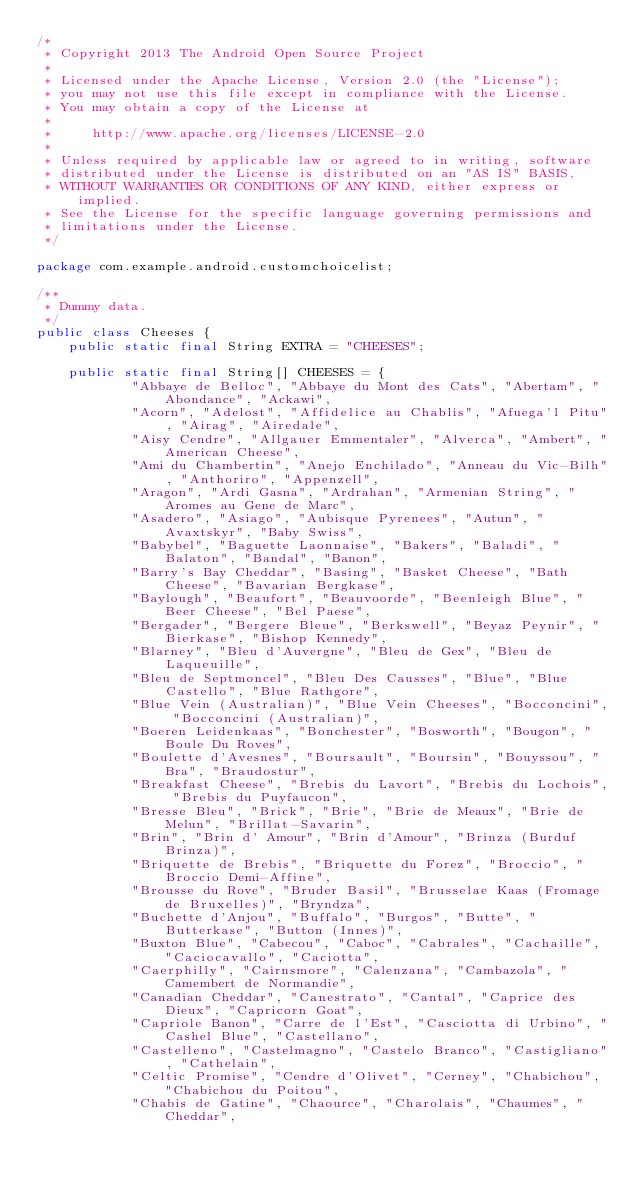Convert code to text. <code><loc_0><loc_0><loc_500><loc_500><_Java_>/*
 * Copyright 2013 The Android Open Source Project
 *
 * Licensed under the Apache License, Version 2.0 (the "License");
 * you may not use this file except in compliance with the License.
 * You may obtain a copy of the License at
 *
 *     http://www.apache.org/licenses/LICENSE-2.0
 *
 * Unless required by applicable law or agreed to in writing, software
 * distributed under the License is distributed on an "AS IS" BASIS,
 * WITHOUT WARRANTIES OR CONDITIONS OF ANY KIND, either express or implied.
 * See the License for the specific language governing permissions and
 * limitations under the License.
 */

package com.example.android.customchoicelist;

/**
 * Dummy data.
 */
public class Cheeses {
    public static final String EXTRA = "CHEESES";

    public static final String[] CHEESES = {
            "Abbaye de Belloc", "Abbaye du Mont des Cats", "Abertam", "Abondance", "Ackawi",
            "Acorn", "Adelost", "Affidelice au Chablis", "Afuega'l Pitu", "Airag", "Airedale",
            "Aisy Cendre", "Allgauer Emmentaler", "Alverca", "Ambert", "American Cheese",
            "Ami du Chambertin", "Anejo Enchilado", "Anneau du Vic-Bilh", "Anthoriro", "Appenzell",
            "Aragon", "Ardi Gasna", "Ardrahan", "Armenian String", "Aromes au Gene de Marc",
            "Asadero", "Asiago", "Aubisque Pyrenees", "Autun", "Avaxtskyr", "Baby Swiss",
            "Babybel", "Baguette Laonnaise", "Bakers", "Baladi", "Balaton", "Bandal", "Banon",
            "Barry's Bay Cheddar", "Basing", "Basket Cheese", "Bath Cheese", "Bavarian Bergkase",
            "Baylough", "Beaufort", "Beauvoorde", "Beenleigh Blue", "Beer Cheese", "Bel Paese",
            "Bergader", "Bergere Bleue", "Berkswell", "Beyaz Peynir", "Bierkase", "Bishop Kennedy",
            "Blarney", "Bleu d'Auvergne", "Bleu de Gex", "Bleu de Laqueuille",
            "Bleu de Septmoncel", "Bleu Des Causses", "Blue", "Blue Castello", "Blue Rathgore",
            "Blue Vein (Australian)", "Blue Vein Cheeses", "Bocconcini", "Bocconcini (Australian)",
            "Boeren Leidenkaas", "Bonchester", "Bosworth", "Bougon", "Boule Du Roves",
            "Boulette d'Avesnes", "Boursault", "Boursin", "Bouyssou", "Bra", "Braudostur",
            "Breakfast Cheese", "Brebis du Lavort", "Brebis du Lochois", "Brebis du Puyfaucon",
            "Bresse Bleu", "Brick", "Brie", "Brie de Meaux", "Brie de Melun", "Brillat-Savarin",
            "Brin", "Brin d' Amour", "Brin d'Amour", "Brinza (Burduf Brinza)",
            "Briquette de Brebis", "Briquette du Forez", "Broccio", "Broccio Demi-Affine",
            "Brousse du Rove", "Bruder Basil", "Brusselae Kaas (Fromage de Bruxelles)", "Bryndza",
            "Buchette d'Anjou", "Buffalo", "Burgos", "Butte", "Butterkase", "Button (Innes)",
            "Buxton Blue", "Cabecou", "Caboc", "Cabrales", "Cachaille", "Caciocavallo", "Caciotta",
            "Caerphilly", "Cairnsmore", "Calenzana", "Cambazola", "Camembert de Normandie",
            "Canadian Cheddar", "Canestrato", "Cantal", "Caprice des Dieux", "Capricorn Goat",
            "Capriole Banon", "Carre de l'Est", "Casciotta di Urbino", "Cashel Blue", "Castellano",
            "Castelleno", "Castelmagno", "Castelo Branco", "Castigliano", "Cathelain",
            "Celtic Promise", "Cendre d'Olivet", "Cerney", "Chabichou", "Chabichou du Poitou",
            "Chabis de Gatine", "Chaource", "Charolais", "Chaumes", "Cheddar",</code> 